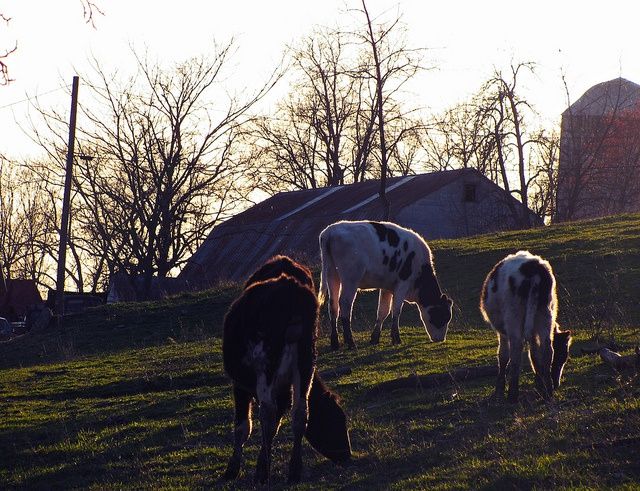Describe the objects in this image and their specific colors. I can see cow in white, black, maroon, and brown tones, cow in white, black, navy, gray, and maroon tones, cow in white, black, purple, and ivory tones, and cow in white, black, maroon, and brown tones in this image. 